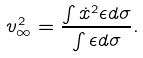<formula> <loc_0><loc_0><loc_500><loc_500>v _ { \infty } ^ { 2 } = \frac { \int \dot { x } ^ { 2 } \epsilon d \sigma } { \int \epsilon d \sigma } .</formula> 